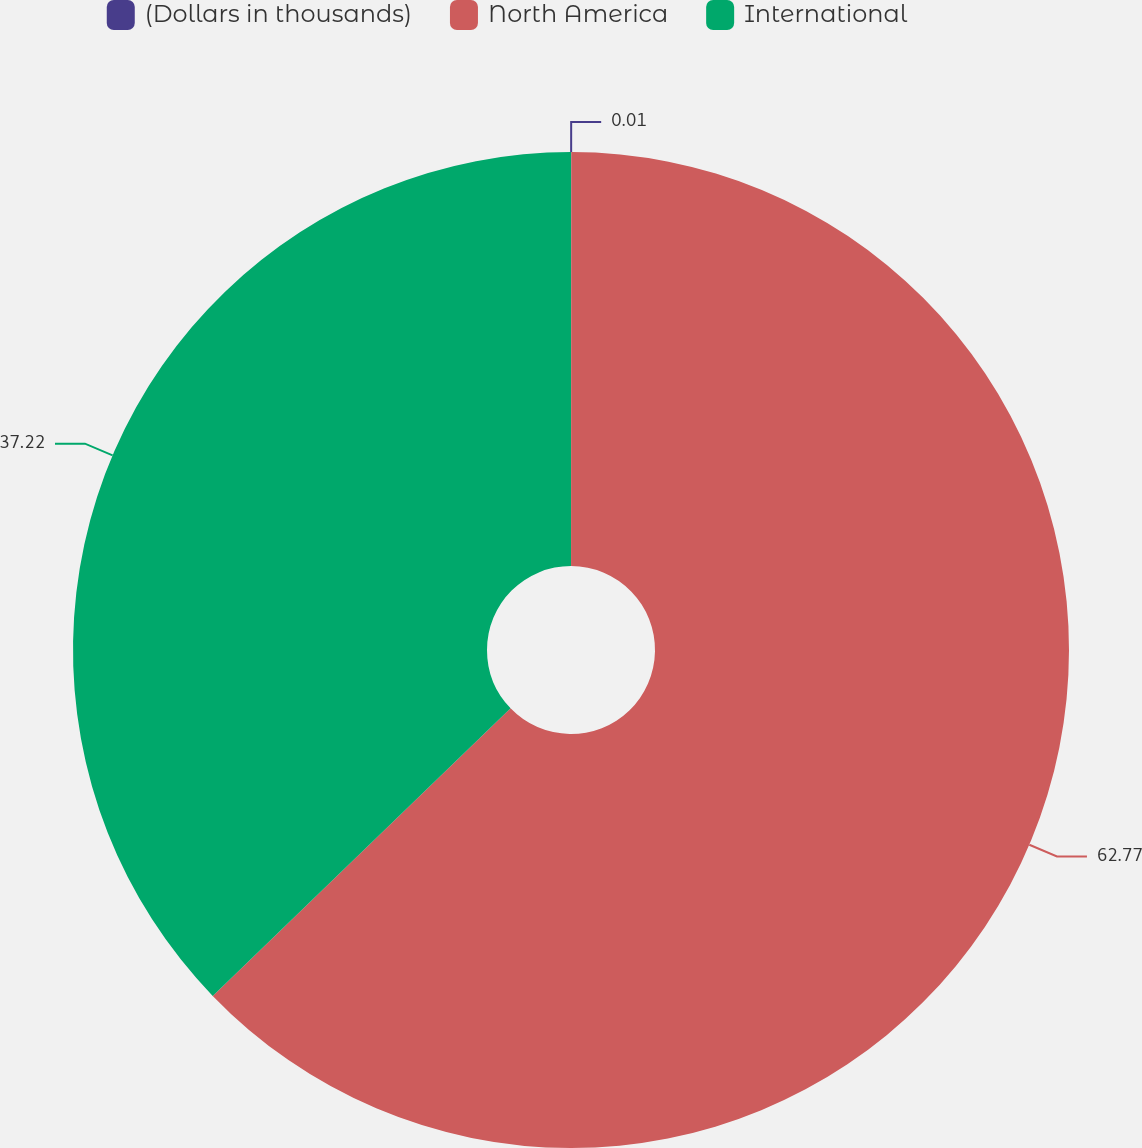Convert chart. <chart><loc_0><loc_0><loc_500><loc_500><pie_chart><fcel>(Dollars in thousands)<fcel>North America<fcel>International<nl><fcel>0.01%<fcel>62.77%<fcel>37.22%<nl></chart> 